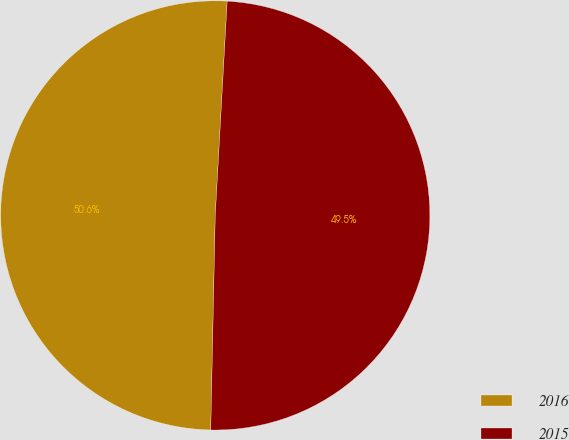Convert chart to OTSL. <chart><loc_0><loc_0><loc_500><loc_500><pie_chart><fcel>2016<fcel>2015<nl><fcel>50.55%<fcel>49.45%<nl></chart> 